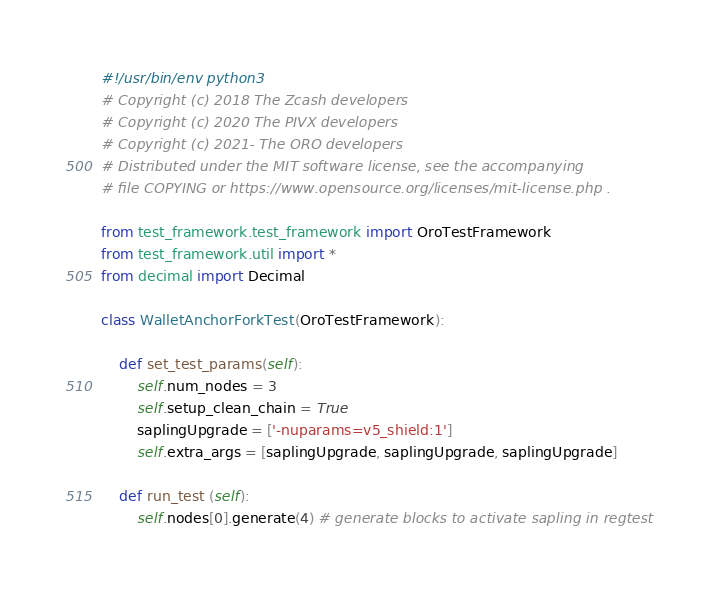Convert code to text. <code><loc_0><loc_0><loc_500><loc_500><_Python_>#!/usr/bin/env python3
# Copyright (c) 2018 The Zcash developers
# Copyright (c) 2020 The PIVX developers
# Copyright (c) 2021- The ORO developers
# Distributed under the MIT software license, see the accompanying
# file COPYING or https://www.opensource.org/licenses/mit-license.php .

from test_framework.test_framework import OroTestFramework
from test_framework.util import *
from decimal import Decimal

class WalletAnchorForkTest(OroTestFramework):

    def set_test_params(self):
        self.num_nodes = 3
        self.setup_clean_chain = True
        saplingUpgrade = ['-nuparams=v5_shield:1']
        self.extra_args = [saplingUpgrade, saplingUpgrade, saplingUpgrade]

    def run_test (self):
        self.nodes[0].generate(4) # generate blocks to activate sapling in regtest</code> 